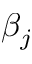<formula> <loc_0><loc_0><loc_500><loc_500>\beta _ { j }</formula> 